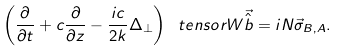Convert formula to latex. <formula><loc_0><loc_0><loc_500><loc_500>\left ( \frac { \partial } { \partial t } + c \frac { \partial } { \partial z } - \frac { i c } { 2 k } \Delta _ { \perp } \right ) \ t e n s o r { W } \vec { \hat { b } } = i N \vec { \sigma } _ { B , A } .</formula> 